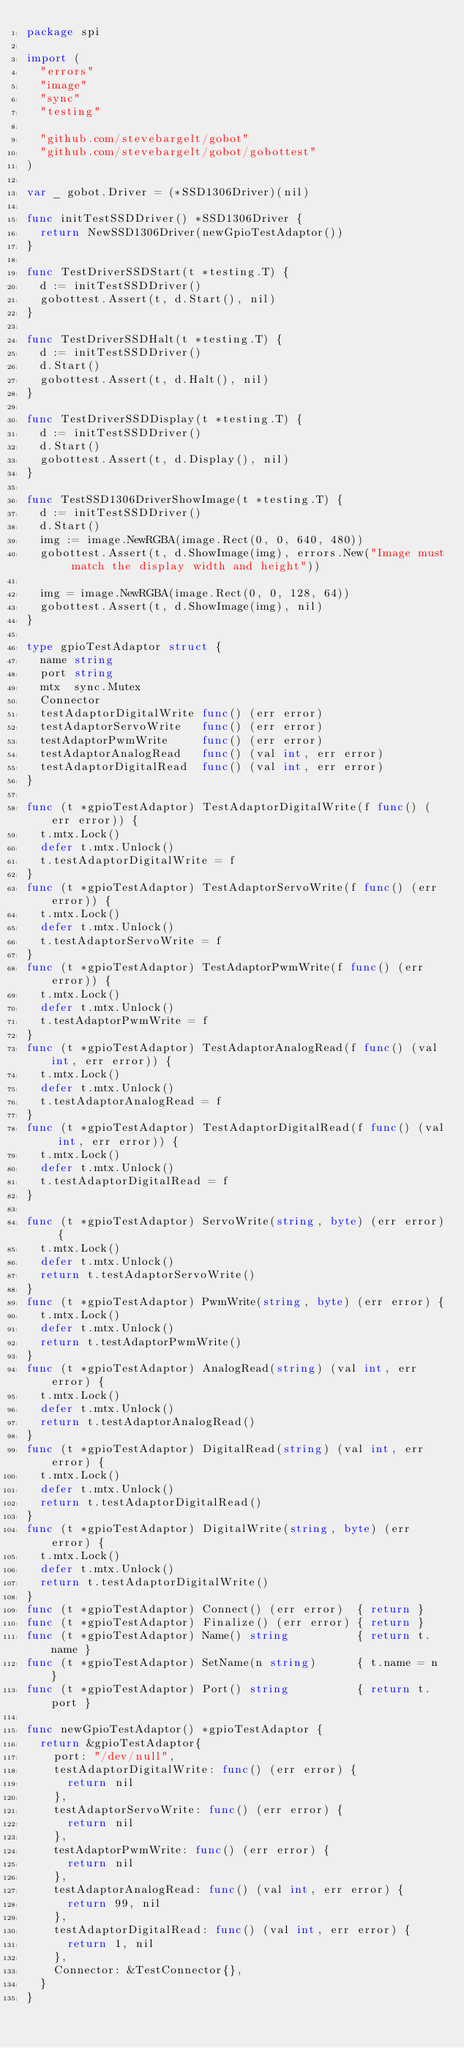Convert code to text. <code><loc_0><loc_0><loc_500><loc_500><_Go_>package spi

import (
	"errors"
	"image"
	"sync"
	"testing"

	"github.com/stevebargelt/gobot"
	"github.com/stevebargelt/gobot/gobottest"
)

var _ gobot.Driver = (*SSD1306Driver)(nil)

func initTestSSDDriver() *SSD1306Driver {
	return NewSSD1306Driver(newGpioTestAdaptor())
}

func TestDriverSSDStart(t *testing.T) {
	d := initTestSSDDriver()
	gobottest.Assert(t, d.Start(), nil)
}

func TestDriverSSDHalt(t *testing.T) {
	d := initTestSSDDriver()
	d.Start()
	gobottest.Assert(t, d.Halt(), nil)
}

func TestDriverSSDDisplay(t *testing.T) {
	d := initTestSSDDriver()
	d.Start()
	gobottest.Assert(t, d.Display(), nil)
}

func TestSSD1306DriverShowImage(t *testing.T) {
	d := initTestSSDDriver()
	d.Start()
	img := image.NewRGBA(image.Rect(0, 0, 640, 480))
	gobottest.Assert(t, d.ShowImage(img), errors.New("Image must match the display width and height"))

	img = image.NewRGBA(image.Rect(0, 0, 128, 64))
	gobottest.Assert(t, d.ShowImage(img), nil)
}

type gpioTestAdaptor struct {
	name string
	port string
	mtx  sync.Mutex
	Connector
	testAdaptorDigitalWrite func() (err error)
	testAdaptorServoWrite   func() (err error)
	testAdaptorPwmWrite     func() (err error)
	testAdaptorAnalogRead   func() (val int, err error)
	testAdaptorDigitalRead  func() (val int, err error)
}

func (t *gpioTestAdaptor) TestAdaptorDigitalWrite(f func() (err error)) {
	t.mtx.Lock()
	defer t.mtx.Unlock()
	t.testAdaptorDigitalWrite = f
}
func (t *gpioTestAdaptor) TestAdaptorServoWrite(f func() (err error)) {
	t.mtx.Lock()
	defer t.mtx.Unlock()
	t.testAdaptorServoWrite = f
}
func (t *gpioTestAdaptor) TestAdaptorPwmWrite(f func() (err error)) {
	t.mtx.Lock()
	defer t.mtx.Unlock()
	t.testAdaptorPwmWrite = f
}
func (t *gpioTestAdaptor) TestAdaptorAnalogRead(f func() (val int, err error)) {
	t.mtx.Lock()
	defer t.mtx.Unlock()
	t.testAdaptorAnalogRead = f
}
func (t *gpioTestAdaptor) TestAdaptorDigitalRead(f func() (val int, err error)) {
	t.mtx.Lock()
	defer t.mtx.Unlock()
	t.testAdaptorDigitalRead = f
}

func (t *gpioTestAdaptor) ServoWrite(string, byte) (err error) {
	t.mtx.Lock()
	defer t.mtx.Unlock()
	return t.testAdaptorServoWrite()
}
func (t *gpioTestAdaptor) PwmWrite(string, byte) (err error) {
	t.mtx.Lock()
	defer t.mtx.Unlock()
	return t.testAdaptorPwmWrite()
}
func (t *gpioTestAdaptor) AnalogRead(string) (val int, err error) {
	t.mtx.Lock()
	defer t.mtx.Unlock()
	return t.testAdaptorAnalogRead()
}
func (t *gpioTestAdaptor) DigitalRead(string) (val int, err error) {
	t.mtx.Lock()
	defer t.mtx.Unlock()
	return t.testAdaptorDigitalRead()
}
func (t *gpioTestAdaptor) DigitalWrite(string, byte) (err error) {
	t.mtx.Lock()
	defer t.mtx.Unlock()
	return t.testAdaptorDigitalWrite()
}
func (t *gpioTestAdaptor) Connect() (err error)  { return }
func (t *gpioTestAdaptor) Finalize() (err error) { return }
func (t *gpioTestAdaptor) Name() string          { return t.name }
func (t *gpioTestAdaptor) SetName(n string)      { t.name = n }
func (t *gpioTestAdaptor) Port() string          { return t.port }

func newGpioTestAdaptor() *gpioTestAdaptor {
	return &gpioTestAdaptor{
		port: "/dev/null",
		testAdaptorDigitalWrite: func() (err error) {
			return nil
		},
		testAdaptorServoWrite: func() (err error) {
			return nil
		},
		testAdaptorPwmWrite: func() (err error) {
			return nil
		},
		testAdaptorAnalogRead: func() (val int, err error) {
			return 99, nil
		},
		testAdaptorDigitalRead: func() (val int, err error) {
			return 1, nil
		},
		Connector: &TestConnector{},
	}
}
</code> 